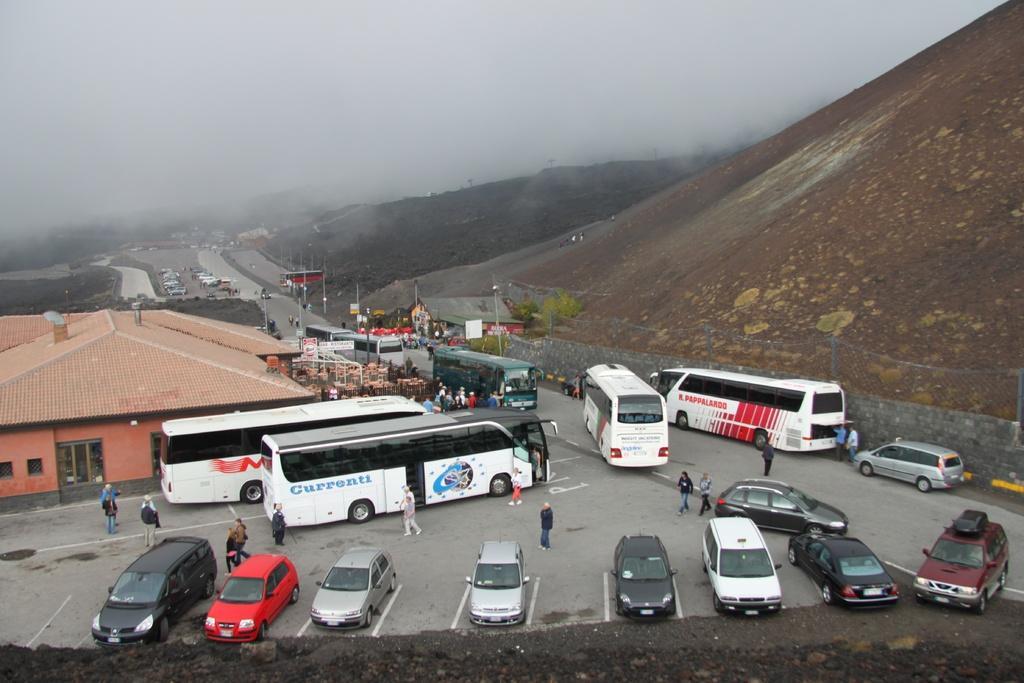Describe this image in one or two sentences. This image consists of buses and cars parked on the road. At the bottom, there is a road. To the left, there is a house. To the right, there is a mountain. At the top, there is a sky. 